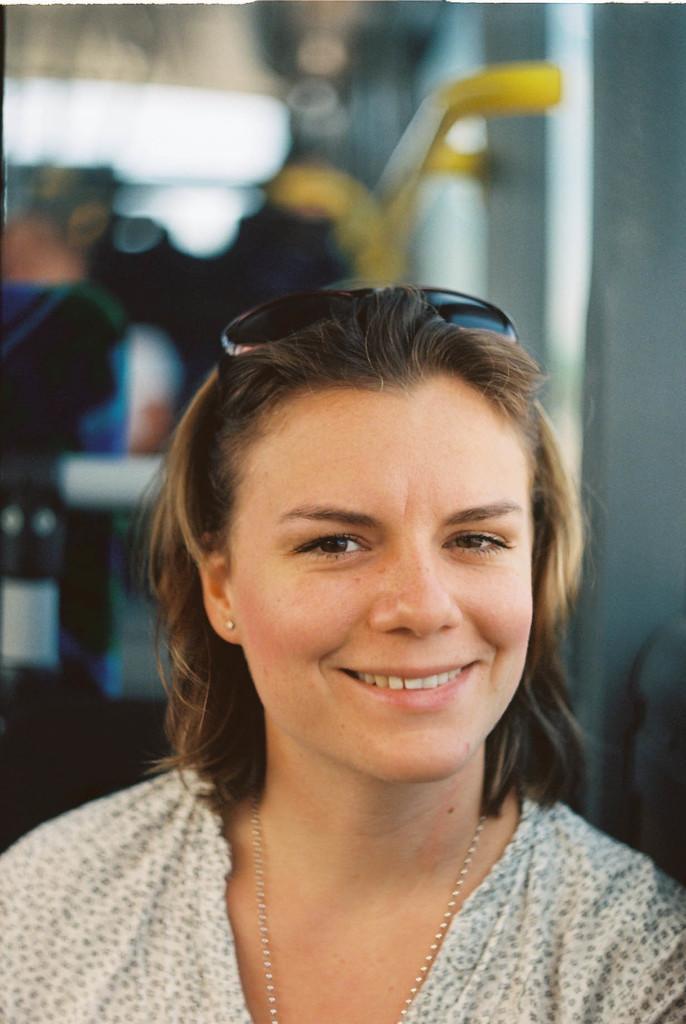How would you summarize this image in a sentence or two? In this picture we can see a woman, she is smiling and in the background we can see some objects and it is blurry. 